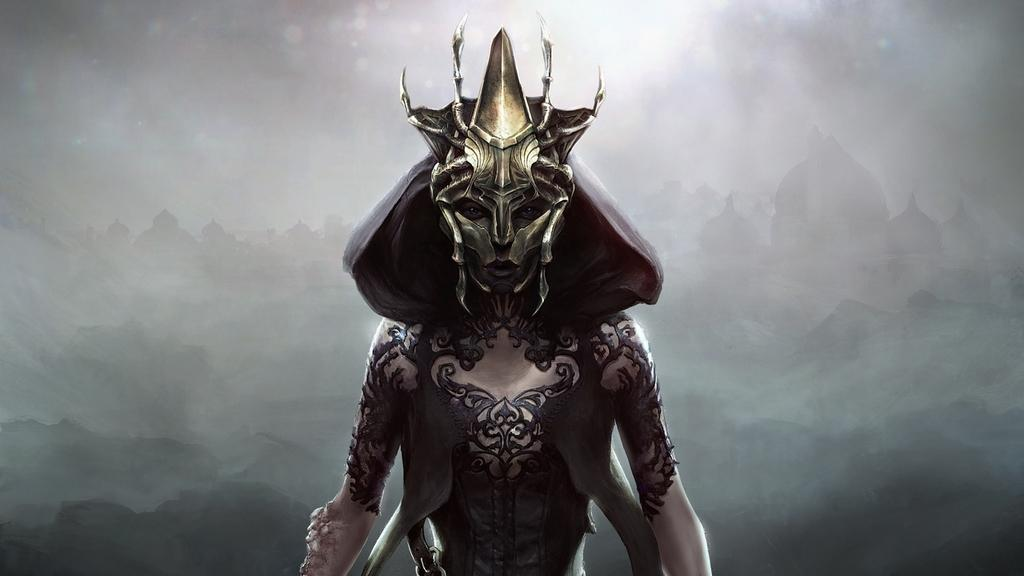Who is the main subject in the image? There is a person in the center of the image. What is the person wearing? The person is wearing a costume. What can be seen in the background of the image? There are buildings and fog visible in the background of the image. What type of loaf is the person holding in the image? There is no loaf present in the image; the person is wearing a costume. 